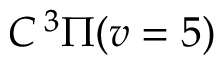Convert formula to latex. <formula><loc_0><loc_0><loc_500><loc_500>C ^ { 3 } \Pi ( v = 5 )</formula> 